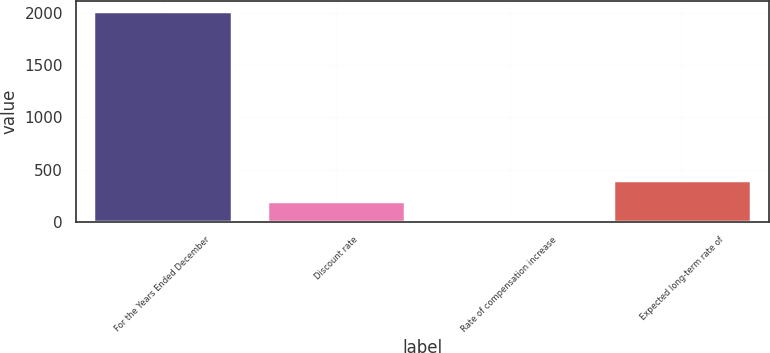Convert chart to OTSL. <chart><loc_0><loc_0><loc_500><loc_500><bar_chart><fcel>For the Years Ended December<fcel>Discount rate<fcel>Rate of compensation increase<fcel>Expected long-term rate of<nl><fcel>2014<fcel>204.36<fcel>3.29<fcel>405.43<nl></chart> 